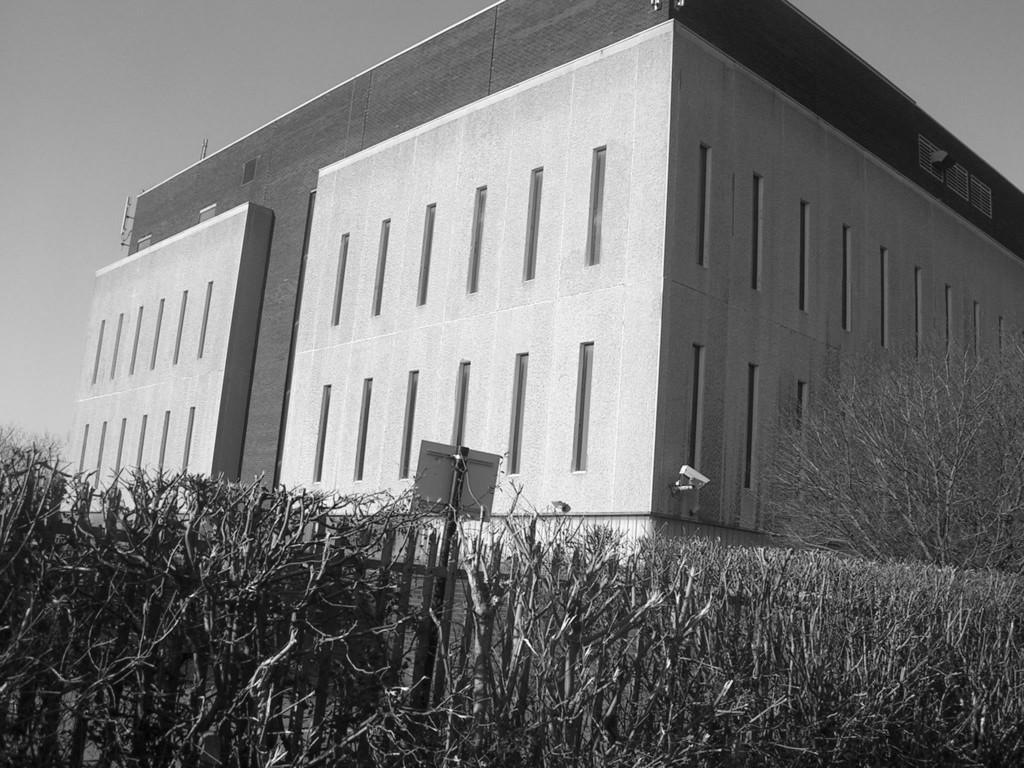What type of structure is visible in the image? There is a building in the image. What other elements can be seen in the image besides the building? There are plants in the image. What type of butter is being used to water the plants in the image? There is no butter present in the image, and the plants are not being watered. 